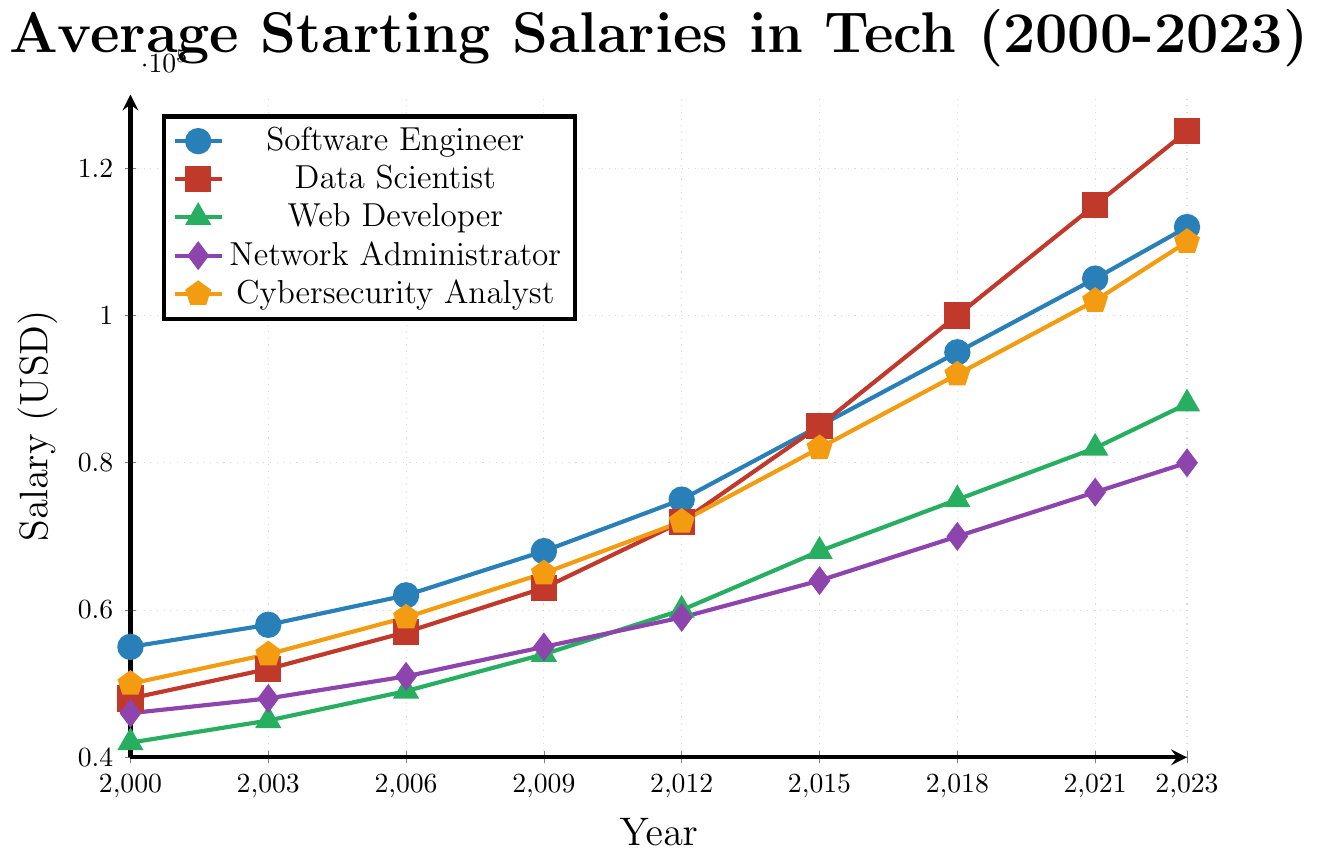what trend can be observed in the starting salary of a data scientist from 2000 to 2023? By looking at the figure, we can see that the starting salary for Data Scientists has increased consistently over the years from $48,000 in 2000 to $125,000 in 2023.
Answer: Consistent increase Which tech job had the highest starting salary in 2023? When examining the figure, the highest point in 2023 is marked for Data Scientists, which is $125,000.
Answer: Data Scientist In which year did Cybersecurity Analysts first surpass the $100,000 mark in starting salary? By following the trend line for Cybersecurity Analyst, we see that it first crosses $100,000 in 2021.
Answer: 2021 Between Software Engineers and Web Developers, which job had a higher starting salary in 2015? Comparing the data points in 2015, Software Engineers have a starting salary of $85,000 while Web Developers have $68,000.
Answer: Software Engineer What is the difference between the starting salaries of Data Scientists and Network Administrators in 2009? According to the figure, in 2009, the starting salary for Data Scientists was $63,000 and for Network Administrators, it was $55,000. The difference is $63,000 - $55,000.
Answer: $8,000 Between which years did Software Engineers experience the largest increase in starting salaries? By observing the changes, between 2018 and 2021, Software Engineers had an increase from $95,000 to $105,000, a difference of $10,000, which is the largest increase.
Answer: 2018-2021 Which job category consistently shows the lowest starting salary across most years? By analyzing the lines, Web Developers have the lowest starting salary in most years from 2000 to 2023.
Answer: Web Developer What is the average starting salary for Network Administrators across the years 2000, 2006, and 2018? Adding the starting salaries for Network Administrators in 2000 ($46,000), 2006 ($51,000), and 2018 ($70,000) and dividing by 3 gives the average: ($46,000 + $51,000 + $70,000) / 3.
Answer: $55,666.67 Between Web Developers and Cybersecurity Analysts, which job had a higher rate of increase in starting salaries from 2000 to 2023? Calculating the difference for Web Developers from $42,000 in 2000 to $88,000 in 2023 (increase of $46,000) and Cybersecurity Analysts from $50,000 in 2000 to $110,000 in 2023 (increase of $60,000), we see that Cybersecurity Analysts had a higher rate.
Answer: Cybersecurity Analyst 